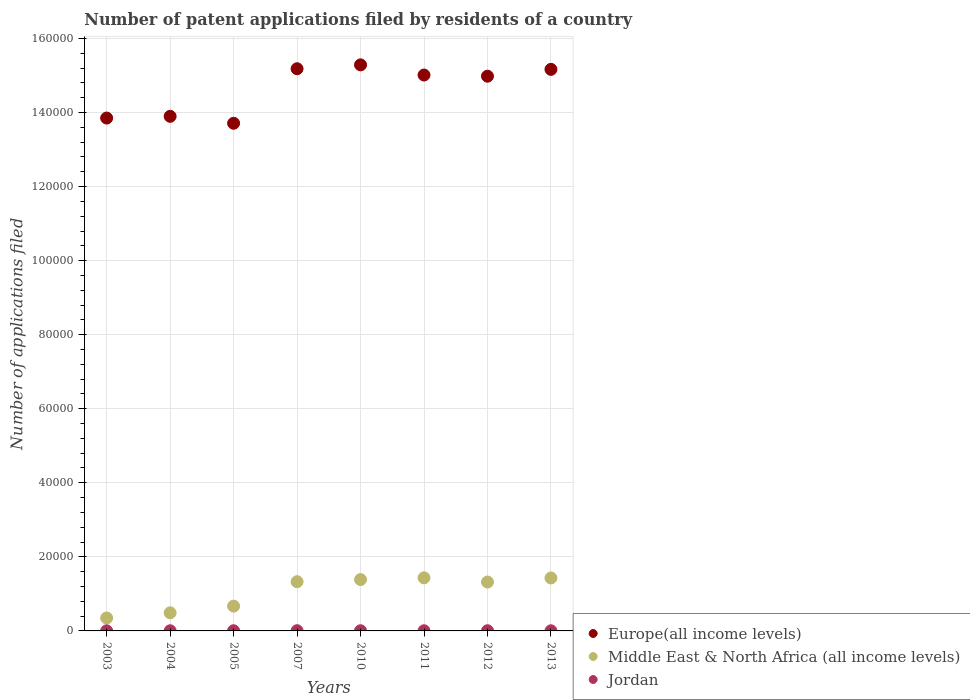Is the number of dotlines equal to the number of legend labels?
Your answer should be very brief. Yes. Across all years, what is the maximum number of applications filed in Middle East & North Africa (all income levels)?
Provide a short and direct response. 1.43e+04. In which year was the number of applications filed in Europe(all income levels) maximum?
Make the answer very short. 2010. In which year was the number of applications filed in Europe(all income levels) minimum?
Offer a very short reply. 2005. What is the total number of applications filed in Middle East & North Africa (all income levels) in the graph?
Your answer should be compact. 8.41e+04. What is the difference between the number of applications filed in Jordan in 2004 and that in 2012?
Keep it short and to the point. -6. What is the difference between the number of applications filed in Jordan in 2004 and the number of applications filed in Europe(all income levels) in 2005?
Your answer should be very brief. -1.37e+05. What is the average number of applications filed in Europe(all income levels) per year?
Provide a succinct answer. 1.46e+05. In the year 2010, what is the difference between the number of applications filed in Europe(all income levels) and number of applications filed in Jordan?
Offer a terse response. 1.53e+05. In how many years, is the number of applications filed in Middle East & North Africa (all income levels) greater than 56000?
Keep it short and to the point. 0. What is the ratio of the number of applications filed in Middle East & North Africa (all income levels) in 2003 to that in 2005?
Make the answer very short. 0.52. Is the difference between the number of applications filed in Europe(all income levels) in 2004 and 2012 greater than the difference between the number of applications filed in Jordan in 2004 and 2012?
Your answer should be very brief. No. What is the difference between the highest and the lowest number of applications filed in Europe(all income levels)?
Ensure brevity in your answer.  1.58e+04. In how many years, is the number of applications filed in Europe(all income levels) greater than the average number of applications filed in Europe(all income levels) taken over all years?
Provide a short and direct response. 5. Is the number of applications filed in Middle East & North Africa (all income levels) strictly less than the number of applications filed in Jordan over the years?
Your response must be concise. No. How many years are there in the graph?
Make the answer very short. 8. What is the difference between two consecutive major ticks on the Y-axis?
Ensure brevity in your answer.  2.00e+04. Are the values on the major ticks of Y-axis written in scientific E-notation?
Provide a short and direct response. No. Does the graph contain any zero values?
Keep it short and to the point. No. Where does the legend appear in the graph?
Provide a succinct answer. Bottom right. How many legend labels are there?
Give a very brief answer. 3. How are the legend labels stacked?
Ensure brevity in your answer.  Vertical. What is the title of the graph?
Your answer should be compact. Number of patent applications filed by residents of a country. Does "Myanmar" appear as one of the legend labels in the graph?
Your response must be concise. No. What is the label or title of the Y-axis?
Offer a terse response. Number of applications filed. What is the Number of applications filed in Europe(all income levels) in 2003?
Offer a terse response. 1.39e+05. What is the Number of applications filed in Middle East & North Africa (all income levels) in 2003?
Offer a terse response. 3484. What is the Number of applications filed in Europe(all income levels) in 2004?
Offer a terse response. 1.39e+05. What is the Number of applications filed in Middle East & North Africa (all income levels) in 2004?
Your response must be concise. 4898. What is the Number of applications filed of Europe(all income levels) in 2005?
Provide a succinct answer. 1.37e+05. What is the Number of applications filed in Middle East & North Africa (all income levels) in 2005?
Keep it short and to the point. 6696. What is the Number of applications filed in Europe(all income levels) in 2007?
Provide a short and direct response. 1.52e+05. What is the Number of applications filed of Middle East & North Africa (all income levels) in 2007?
Offer a terse response. 1.33e+04. What is the Number of applications filed of Europe(all income levels) in 2010?
Your answer should be compact. 1.53e+05. What is the Number of applications filed of Middle East & North Africa (all income levels) in 2010?
Your response must be concise. 1.39e+04. What is the Number of applications filed in Europe(all income levels) in 2011?
Offer a very short reply. 1.50e+05. What is the Number of applications filed in Middle East & North Africa (all income levels) in 2011?
Offer a very short reply. 1.43e+04. What is the Number of applications filed in Europe(all income levels) in 2012?
Ensure brevity in your answer.  1.50e+05. What is the Number of applications filed of Middle East & North Africa (all income levels) in 2012?
Your answer should be compact. 1.32e+04. What is the Number of applications filed of Europe(all income levels) in 2013?
Offer a very short reply. 1.52e+05. What is the Number of applications filed in Middle East & North Africa (all income levels) in 2013?
Provide a succinct answer. 1.43e+04. What is the Number of applications filed in Jordan in 2013?
Your answer should be compact. 35. Across all years, what is the maximum Number of applications filed in Europe(all income levels)?
Your answer should be compact. 1.53e+05. Across all years, what is the maximum Number of applications filed of Middle East & North Africa (all income levels)?
Provide a succinct answer. 1.43e+04. Across all years, what is the maximum Number of applications filed of Jordan?
Offer a very short reply. 59. Across all years, what is the minimum Number of applications filed in Europe(all income levels)?
Give a very brief answer. 1.37e+05. Across all years, what is the minimum Number of applications filed in Middle East & North Africa (all income levels)?
Your response must be concise. 3484. What is the total Number of applications filed in Europe(all income levels) in the graph?
Offer a terse response. 1.17e+06. What is the total Number of applications filed in Middle East & North Africa (all income levels) in the graph?
Give a very brief answer. 8.41e+04. What is the total Number of applications filed in Jordan in the graph?
Keep it short and to the point. 343. What is the difference between the Number of applications filed in Europe(all income levels) in 2003 and that in 2004?
Keep it short and to the point. -467. What is the difference between the Number of applications filed in Middle East & North Africa (all income levels) in 2003 and that in 2004?
Your answer should be compact. -1414. What is the difference between the Number of applications filed in Jordan in 2003 and that in 2004?
Your answer should be compact. -17. What is the difference between the Number of applications filed in Europe(all income levels) in 2003 and that in 2005?
Provide a short and direct response. 1405. What is the difference between the Number of applications filed in Middle East & North Africa (all income levels) in 2003 and that in 2005?
Ensure brevity in your answer.  -3212. What is the difference between the Number of applications filed in Europe(all income levels) in 2003 and that in 2007?
Provide a succinct answer. -1.33e+04. What is the difference between the Number of applications filed in Middle East & North Africa (all income levels) in 2003 and that in 2007?
Your answer should be compact. -9813. What is the difference between the Number of applications filed in Jordan in 2003 and that in 2007?
Make the answer very short. -34. What is the difference between the Number of applications filed in Europe(all income levels) in 2003 and that in 2010?
Ensure brevity in your answer.  -1.44e+04. What is the difference between the Number of applications filed of Middle East & North Africa (all income levels) in 2003 and that in 2010?
Give a very brief answer. -1.04e+04. What is the difference between the Number of applications filed of Jordan in 2003 and that in 2010?
Your response must be concise. -20. What is the difference between the Number of applications filed in Europe(all income levels) in 2003 and that in 2011?
Offer a very short reply. -1.16e+04. What is the difference between the Number of applications filed in Middle East & North Africa (all income levels) in 2003 and that in 2011?
Provide a short and direct response. -1.09e+04. What is the difference between the Number of applications filed in Europe(all income levels) in 2003 and that in 2012?
Make the answer very short. -1.13e+04. What is the difference between the Number of applications filed of Middle East & North Africa (all income levels) in 2003 and that in 2012?
Your response must be concise. -9727. What is the difference between the Number of applications filed of Europe(all income levels) in 2003 and that in 2013?
Provide a succinct answer. -1.32e+04. What is the difference between the Number of applications filed of Middle East & North Africa (all income levels) in 2003 and that in 2013?
Give a very brief answer. -1.08e+04. What is the difference between the Number of applications filed in Europe(all income levels) in 2004 and that in 2005?
Ensure brevity in your answer.  1872. What is the difference between the Number of applications filed in Middle East & North Africa (all income levels) in 2004 and that in 2005?
Your answer should be compact. -1798. What is the difference between the Number of applications filed of Europe(all income levels) in 2004 and that in 2007?
Provide a succinct answer. -1.29e+04. What is the difference between the Number of applications filed of Middle East & North Africa (all income levels) in 2004 and that in 2007?
Keep it short and to the point. -8399. What is the difference between the Number of applications filed of Jordan in 2004 and that in 2007?
Your answer should be compact. -17. What is the difference between the Number of applications filed in Europe(all income levels) in 2004 and that in 2010?
Provide a short and direct response. -1.39e+04. What is the difference between the Number of applications filed of Middle East & North Africa (all income levels) in 2004 and that in 2010?
Make the answer very short. -8971. What is the difference between the Number of applications filed in Jordan in 2004 and that in 2010?
Keep it short and to the point. -3. What is the difference between the Number of applications filed in Europe(all income levels) in 2004 and that in 2011?
Offer a terse response. -1.12e+04. What is the difference between the Number of applications filed of Middle East & North Africa (all income levels) in 2004 and that in 2011?
Your response must be concise. -9439. What is the difference between the Number of applications filed in Jordan in 2004 and that in 2011?
Offer a very short reply. 2. What is the difference between the Number of applications filed in Europe(all income levels) in 2004 and that in 2012?
Offer a very short reply. -1.08e+04. What is the difference between the Number of applications filed of Middle East & North Africa (all income levels) in 2004 and that in 2012?
Ensure brevity in your answer.  -8313. What is the difference between the Number of applications filed of Europe(all income levels) in 2004 and that in 2013?
Your answer should be very brief. -1.27e+04. What is the difference between the Number of applications filed of Middle East & North Africa (all income levels) in 2004 and that in 2013?
Your response must be concise. -9408. What is the difference between the Number of applications filed of Europe(all income levels) in 2005 and that in 2007?
Your answer should be very brief. -1.47e+04. What is the difference between the Number of applications filed of Middle East & North Africa (all income levels) in 2005 and that in 2007?
Make the answer very short. -6601. What is the difference between the Number of applications filed of Europe(all income levels) in 2005 and that in 2010?
Provide a succinct answer. -1.58e+04. What is the difference between the Number of applications filed of Middle East & North Africa (all income levels) in 2005 and that in 2010?
Your answer should be compact. -7173. What is the difference between the Number of applications filed in Europe(all income levels) in 2005 and that in 2011?
Offer a very short reply. -1.30e+04. What is the difference between the Number of applications filed of Middle East & North Africa (all income levels) in 2005 and that in 2011?
Offer a very short reply. -7641. What is the difference between the Number of applications filed in Europe(all income levels) in 2005 and that in 2012?
Your answer should be compact. -1.27e+04. What is the difference between the Number of applications filed of Middle East & North Africa (all income levels) in 2005 and that in 2012?
Provide a succinct answer. -6515. What is the difference between the Number of applications filed in Jordan in 2005 and that in 2012?
Ensure brevity in your answer.  1. What is the difference between the Number of applications filed of Europe(all income levels) in 2005 and that in 2013?
Your answer should be compact. -1.46e+04. What is the difference between the Number of applications filed in Middle East & North Africa (all income levels) in 2005 and that in 2013?
Your answer should be compact. -7610. What is the difference between the Number of applications filed in Jordan in 2005 and that in 2013?
Keep it short and to the point. 14. What is the difference between the Number of applications filed in Europe(all income levels) in 2007 and that in 2010?
Provide a succinct answer. -1043. What is the difference between the Number of applications filed in Middle East & North Africa (all income levels) in 2007 and that in 2010?
Offer a terse response. -572. What is the difference between the Number of applications filed of Europe(all income levels) in 2007 and that in 2011?
Offer a terse response. 1699. What is the difference between the Number of applications filed in Middle East & North Africa (all income levels) in 2007 and that in 2011?
Make the answer very short. -1040. What is the difference between the Number of applications filed in Jordan in 2007 and that in 2011?
Offer a very short reply. 19. What is the difference between the Number of applications filed of Europe(all income levels) in 2007 and that in 2012?
Provide a short and direct response. 2016. What is the difference between the Number of applications filed in Europe(all income levels) in 2007 and that in 2013?
Provide a short and direct response. 171. What is the difference between the Number of applications filed in Middle East & North Africa (all income levels) in 2007 and that in 2013?
Give a very brief answer. -1009. What is the difference between the Number of applications filed in Europe(all income levels) in 2010 and that in 2011?
Make the answer very short. 2742. What is the difference between the Number of applications filed of Middle East & North Africa (all income levels) in 2010 and that in 2011?
Offer a terse response. -468. What is the difference between the Number of applications filed in Jordan in 2010 and that in 2011?
Keep it short and to the point. 5. What is the difference between the Number of applications filed in Europe(all income levels) in 2010 and that in 2012?
Your answer should be very brief. 3059. What is the difference between the Number of applications filed of Middle East & North Africa (all income levels) in 2010 and that in 2012?
Your answer should be very brief. 658. What is the difference between the Number of applications filed in Jordan in 2010 and that in 2012?
Offer a very short reply. -3. What is the difference between the Number of applications filed of Europe(all income levels) in 2010 and that in 2013?
Provide a short and direct response. 1214. What is the difference between the Number of applications filed in Middle East & North Africa (all income levels) in 2010 and that in 2013?
Provide a short and direct response. -437. What is the difference between the Number of applications filed in Jordan in 2010 and that in 2013?
Make the answer very short. 10. What is the difference between the Number of applications filed of Europe(all income levels) in 2011 and that in 2012?
Give a very brief answer. 317. What is the difference between the Number of applications filed in Middle East & North Africa (all income levels) in 2011 and that in 2012?
Your answer should be compact. 1126. What is the difference between the Number of applications filed in Europe(all income levels) in 2011 and that in 2013?
Your response must be concise. -1528. What is the difference between the Number of applications filed of Middle East & North Africa (all income levels) in 2011 and that in 2013?
Your answer should be compact. 31. What is the difference between the Number of applications filed of Jordan in 2011 and that in 2013?
Your answer should be compact. 5. What is the difference between the Number of applications filed in Europe(all income levels) in 2012 and that in 2013?
Offer a very short reply. -1845. What is the difference between the Number of applications filed in Middle East & North Africa (all income levels) in 2012 and that in 2013?
Make the answer very short. -1095. What is the difference between the Number of applications filed in Jordan in 2012 and that in 2013?
Make the answer very short. 13. What is the difference between the Number of applications filed in Europe(all income levels) in 2003 and the Number of applications filed in Middle East & North Africa (all income levels) in 2004?
Provide a short and direct response. 1.34e+05. What is the difference between the Number of applications filed of Europe(all income levels) in 2003 and the Number of applications filed of Jordan in 2004?
Your answer should be very brief. 1.38e+05. What is the difference between the Number of applications filed of Middle East & North Africa (all income levels) in 2003 and the Number of applications filed of Jordan in 2004?
Your answer should be compact. 3442. What is the difference between the Number of applications filed of Europe(all income levels) in 2003 and the Number of applications filed of Middle East & North Africa (all income levels) in 2005?
Provide a succinct answer. 1.32e+05. What is the difference between the Number of applications filed in Europe(all income levels) in 2003 and the Number of applications filed in Jordan in 2005?
Offer a very short reply. 1.38e+05. What is the difference between the Number of applications filed of Middle East & North Africa (all income levels) in 2003 and the Number of applications filed of Jordan in 2005?
Your answer should be very brief. 3435. What is the difference between the Number of applications filed in Europe(all income levels) in 2003 and the Number of applications filed in Middle East & North Africa (all income levels) in 2007?
Offer a very short reply. 1.25e+05. What is the difference between the Number of applications filed of Europe(all income levels) in 2003 and the Number of applications filed of Jordan in 2007?
Provide a succinct answer. 1.38e+05. What is the difference between the Number of applications filed in Middle East & North Africa (all income levels) in 2003 and the Number of applications filed in Jordan in 2007?
Ensure brevity in your answer.  3425. What is the difference between the Number of applications filed in Europe(all income levels) in 2003 and the Number of applications filed in Middle East & North Africa (all income levels) in 2010?
Offer a very short reply. 1.25e+05. What is the difference between the Number of applications filed of Europe(all income levels) in 2003 and the Number of applications filed of Jordan in 2010?
Ensure brevity in your answer.  1.38e+05. What is the difference between the Number of applications filed in Middle East & North Africa (all income levels) in 2003 and the Number of applications filed in Jordan in 2010?
Keep it short and to the point. 3439. What is the difference between the Number of applications filed in Europe(all income levels) in 2003 and the Number of applications filed in Middle East & North Africa (all income levels) in 2011?
Keep it short and to the point. 1.24e+05. What is the difference between the Number of applications filed in Europe(all income levels) in 2003 and the Number of applications filed in Jordan in 2011?
Ensure brevity in your answer.  1.38e+05. What is the difference between the Number of applications filed in Middle East & North Africa (all income levels) in 2003 and the Number of applications filed in Jordan in 2011?
Ensure brevity in your answer.  3444. What is the difference between the Number of applications filed of Europe(all income levels) in 2003 and the Number of applications filed of Middle East & North Africa (all income levels) in 2012?
Keep it short and to the point. 1.25e+05. What is the difference between the Number of applications filed in Europe(all income levels) in 2003 and the Number of applications filed in Jordan in 2012?
Give a very brief answer. 1.38e+05. What is the difference between the Number of applications filed in Middle East & North Africa (all income levels) in 2003 and the Number of applications filed in Jordan in 2012?
Your answer should be compact. 3436. What is the difference between the Number of applications filed of Europe(all income levels) in 2003 and the Number of applications filed of Middle East & North Africa (all income levels) in 2013?
Keep it short and to the point. 1.24e+05. What is the difference between the Number of applications filed in Europe(all income levels) in 2003 and the Number of applications filed in Jordan in 2013?
Ensure brevity in your answer.  1.38e+05. What is the difference between the Number of applications filed in Middle East & North Africa (all income levels) in 2003 and the Number of applications filed in Jordan in 2013?
Your answer should be compact. 3449. What is the difference between the Number of applications filed in Europe(all income levels) in 2004 and the Number of applications filed in Middle East & North Africa (all income levels) in 2005?
Your response must be concise. 1.32e+05. What is the difference between the Number of applications filed in Europe(all income levels) in 2004 and the Number of applications filed in Jordan in 2005?
Your answer should be compact. 1.39e+05. What is the difference between the Number of applications filed of Middle East & North Africa (all income levels) in 2004 and the Number of applications filed of Jordan in 2005?
Provide a short and direct response. 4849. What is the difference between the Number of applications filed of Europe(all income levels) in 2004 and the Number of applications filed of Middle East & North Africa (all income levels) in 2007?
Your response must be concise. 1.26e+05. What is the difference between the Number of applications filed in Europe(all income levels) in 2004 and the Number of applications filed in Jordan in 2007?
Your response must be concise. 1.39e+05. What is the difference between the Number of applications filed of Middle East & North Africa (all income levels) in 2004 and the Number of applications filed of Jordan in 2007?
Offer a terse response. 4839. What is the difference between the Number of applications filed in Europe(all income levels) in 2004 and the Number of applications filed in Middle East & North Africa (all income levels) in 2010?
Provide a short and direct response. 1.25e+05. What is the difference between the Number of applications filed of Europe(all income levels) in 2004 and the Number of applications filed of Jordan in 2010?
Give a very brief answer. 1.39e+05. What is the difference between the Number of applications filed of Middle East & North Africa (all income levels) in 2004 and the Number of applications filed of Jordan in 2010?
Make the answer very short. 4853. What is the difference between the Number of applications filed of Europe(all income levels) in 2004 and the Number of applications filed of Middle East & North Africa (all income levels) in 2011?
Keep it short and to the point. 1.25e+05. What is the difference between the Number of applications filed of Europe(all income levels) in 2004 and the Number of applications filed of Jordan in 2011?
Offer a terse response. 1.39e+05. What is the difference between the Number of applications filed in Middle East & North Africa (all income levels) in 2004 and the Number of applications filed in Jordan in 2011?
Your response must be concise. 4858. What is the difference between the Number of applications filed in Europe(all income levels) in 2004 and the Number of applications filed in Middle East & North Africa (all income levels) in 2012?
Ensure brevity in your answer.  1.26e+05. What is the difference between the Number of applications filed of Europe(all income levels) in 2004 and the Number of applications filed of Jordan in 2012?
Your response must be concise. 1.39e+05. What is the difference between the Number of applications filed of Middle East & North Africa (all income levels) in 2004 and the Number of applications filed of Jordan in 2012?
Ensure brevity in your answer.  4850. What is the difference between the Number of applications filed in Europe(all income levels) in 2004 and the Number of applications filed in Middle East & North Africa (all income levels) in 2013?
Your answer should be compact. 1.25e+05. What is the difference between the Number of applications filed in Europe(all income levels) in 2004 and the Number of applications filed in Jordan in 2013?
Make the answer very short. 1.39e+05. What is the difference between the Number of applications filed of Middle East & North Africa (all income levels) in 2004 and the Number of applications filed of Jordan in 2013?
Make the answer very short. 4863. What is the difference between the Number of applications filed of Europe(all income levels) in 2005 and the Number of applications filed of Middle East & North Africa (all income levels) in 2007?
Provide a short and direct response. 1.24e+05. What is the difference between the Number of applications filed of Europe(all income levels) in 2005 and the Number of applications filed of Jordan in 2007?
Your response must be concise. 1.37e+05. What is the difference between the Number of applications filed of Middle East & North Africa (all income levels) in 2005 and the Number of applications filed of Jordan in 2007?
Offer a very short reply. 6637. What is the difference between the Number of applications filed of Europe(all income levels) in 2005 and the Number of applications filed of Middle East & North Africa (all income levels) in 2010?
Provide a succinct answer. 1.23e+05. What is the difference between the Number of applications filed of Europe(all income levels) in 2005 and the Number of applications filed of Jordan in 2010?
Your answer should be very brief. 1.37e+05. What is the difference between the Number of applications filed of Middle East & North Africa (all income levels) in 2005 and the Number of applications filed of Jordan in 2010?
Provide a succinct answer. 6651. What is the difference between the Number of applications filed of Europe(all income levels) in 2005 and the Number of applications filed of Middle East & North Africa (all income levels) in 2011?
Make the answer very short. 1.23e+05. What is the difference between the Number of applications filed of Europe(all income levels) in 2005 and the Number of applications filed of Jordan in 2011?
Your answer should be very brief. 1.37e+05. What is the difference between the Number of applications filed of Middle East & North Africa (all income levels) in 2005 and the Number of applications filed of Jordan in 2011?
Make the answer very short. 6656. What is the difference between the Number of applications filed in Europe(all income levels) in 2005 and the Number of applications filed in Middle East & North Africa (all income levels) in 2012?
Offer a terse response. 1.24e+05. What is the difference between the Number of applications filed of Europe(all income levels) in 2005 and the Number of applications filed of Jordan in 2012?
Your answer should be compact. 1.37e+05. What is the difference between the Number of applications filed of Middle East & North Africa (all income levels) in 2005 and the Number of applications filed of Jordan in 2012?
Your response must be concise. 6648. What is the difference between the Number of applications filed in Europe(all income levels) in 2005 and the Number of applications filed in Middle East & North Africa (all income levels) in 2013?
Ensure brevity in your answer.  1.23e+05. What is the difference between the Number of applications filed of Europe(all income levels) in 2005 and the Number of applications filed of Jordan in 2013?
Your answer should be compact. 1.37e+05. What is the difference between the Number of applications filed in Middle East & North Africa (all income levels) in 2005 and the Number of applications filed in Jordan in 2013?
Make the answer very short. 6661. What is the difference between the Number of applications filed in Europe(all income levels) in 2007 and the Number of applications filed in Middle East & North Africa (all income levels) in 2010?
Offer a very short reply. 1.38e+05. What is the difference between the Number of applications filed in Europe(all income levels) in 2007 and the Number of applications filed in Jordan in 2010?
Your answer should be compact. 1.52e+05. What is the difference between the Number of applications filed in Middle East & North Africa (all income levels) in 2007 and the Number of applications filed in Jordan in 2010?
Offer a very short reply. 1.33e+04. What is the difference between the Number of applications filed in Europe(all income levels) in 2007 and the Number of applications filed in Middle East & North Africa (all income levels) in 2011?
Offer a very short reply. 1.37e+05. What is the difference between the Number of applications filed in Europe(all income levels) in 2007 and the Number of applications filed in Jordan in 2011?
Keep it short and to the point. 1.52e+05. What is the difference between the Number of applications filed of Middle East & North Africa (all income levels) in 2007 and the Number of applications filed of Jordan in 2011?
Make the answer very short. 1.33e+04. What is the difference between the Number of applications filed in Europe(all income levels) in 2007 and the Number of applications filed in Middle East & North Africa (all income levels) in 2012?
Your answer should be compact. 1.39e+05. What is the difference between the Number of applications filed in Europe(all income levels) in 2007 and the Number of applications filed in Jordan in 2012?
Provide a short and direct response. 1.52e+05. What is the difference between the Number of applications filed in Middle East & North Africa (all income levels) in 2007 and the Number of applications filed in Jordan in 2012?
Make the answer very short. 1.32e+04. What is the difference between the Number of applications filed of Europe(all income levels) in 2007 and the Number of applications filed of Middle East & North Africa (all income levels) in 2013?
Make the answer very short. 1.38e+05. What is the difference between the Number of applications filed of Europe(all income levels) in 2007 and the Number of applications filed of Jordan in 2013?
Ensure brevity in your answer.  1.52e+05. What is the difference between the Number of applications filed of Middle East & North Africa (all income levels) in 2007 and the Number of applications filed of Jordan in 2013?
Make the answer very short. 1.33e+04. What is the difference between the Number of applications filed of Europe(all income levels) in 2010 and the Number of applications filed of Middle East & North Africa (all income levels) in 2011?
Your answer should be compact. 1.39e+05. What is the difference between the Number of applications filed of Europe(all income levels) in 2010 and the Number of applications filed of Jordan in 2011?
Offer a terse response. 1.53e+05. What is the difference between the Number of applications filed in Middle East & North Africa (all income levels) in 2010 and the Number of applications filed in Jordan in 2011?
Provide a succinct answer. 1.38e+04. What is the difference between the Number of applications filed in Europe(all income levels) in 2010 and the Number of applications filed in Middle East & North Africa (all income levels) in 2012?
Your answer should be very brief. 1.40e+05. What is the difference between the Number of applications filed of Europe(all income levels) in 2010 and the Number of applications filed of Jordan in 2012?
Ensure brevity in your answer.  1.53e+05. What is the difference between the Number of applications filed of Middle East & North Africa (all income levels) in 2010 and the Number of applications filed of Jordan in 2012?
Your answer should be very brief. 1.38e+04. What is the difference between the Number of applications filed in Europe(all income levels) in 2010 and the Number of applications filed in Middle East & North Africa (all income levels) in 2013?
Your answer should be compact. 1.39e+05. What is the difference between the Number of applications filed in Europe(all income levels) in 2010 and the Number of applications filed in Jordan in 2013?
Offer a terse response. 1.53e+05. What is the difference between the Number of applications filed in Middle East & North Africa (all income levels) in 2010 and the Number of applications filed in Jordan in 2013?
Provide a succinct answer. 1.38e+04. What is the difference between the Number of applications filed of Europe(all income levels) in 2011 and the Number of applications filed of Middle East & North Africa (all income levels) in 2012?
Provide a succinct answer. 1.37e+05. What is the difference between the Number of applications filed in Europe(all income levels) in 2011 and the Number of applications filed in Jordan in 2012?
Your response must be concise. 1.50e+05. What is the difference between the Number of applications filed of Middle East & North Africa (all income levels) in 2011 and the Number of applications filed of Jordan in 2012?
Keep it short and to the point. 1.43e+04. What is the difference between the Number of applications filed in Europe(all income levels) in 2011 and the Number of applications filed in Middle East & North Africa (all income levels) in 2013?
Your answer should be very brief. 1.36e+05. What is the difference between the Number of applications filed of Europe(all income levels) in 2011 and the Number of applications filed of Jordan in 2013?
Give a very brief answer. 1.50e+05. What is the difference between the Number of applications filed of Middle East & North Africa (all income levels) in 2011 and the Number of applications filed of Jordan in 2013?
Give a very brief answer. 1.43e+04. What is the difference between the Number of applications filed of Europe(all income levels) in 2012 and the Number of applications filed of Middle East & North Africa (all income levels) in 2013?
Provide a succinct answer. 1.36e+05. What is the difference between the Number of applications filed of Europe(all income levels) in 2012 and the Number of applications filed of Jordan in 2013?
Make the answer very short. 1.50e+05. What is the difference between the Number of applications filed in Middle East & North Africa (all income levels) in 2012 and the Number of applications filed in Jordan in 2013?
Provide a short and direct response. 1.32e+04. What is the average Number of applications filed in Europe(all income levels) per year?
Keep it short and to the point. 1.46e+05. What is the average Number of applications filed in Middle East & North Africa (all income levels) per year?
Give a very brief answer. 1.05e+04. What is the average Number of applications filed of Jordan per year?
Make the answer very short. 42.88. In the year 2003, what is the difference between the Number of applications filed of Europe(all income levels) and Number of applications filed of Middle East & North Africa (all income levels)?
Your response must be concise. 1.35e+05. In the year 2003, what is the difference between the Number of applications filed in Europe(all income levels) and Number of applications filed in Jordan?
Offer a terse response. 1.38e+05. In the year 2003, what is the difference between the Number of applications filed of Middle East & North Africa (all income levels) and Number of applications filed of Jordan?
Offer a very short reply. 3459. In the year 2004, what is the difference between the Number of applications filed in Europe(all income levels) and Number of applications filed in Middle East & North Africa (all income levels)?
Provide a short and direct response. 1.34e+05. In the year 2004, what is the difference between the Number of applications filed in Europe(all income levels) and Number of applications filed in Jordan?
Ensure brevity in your answer.  1.39e+05. In the year 2004, what is the difference between the Number of applications filed of Middle East & North Africa (all income levels) and Number of applications filed of Jordan?
Ensure brevity in your answer.  4856. In the year 2005, what is the difference between the Number of applications filed in Europe(all income levels) and Number of applications filed in Middle East & North Africa (all income levels)?
Offer a terse response. 1.30e+05. In the year 2005, what is the difference between the Number of applications filed of Europe(all income levels) and Number of applications filed of Jordan?
Your answer should be compact. 1.37e+05. In the year 2005, what is the difference between the Number of applications filed of Middle East & North Africa (all income levels) and Number of applications filed of Jordan?
Offer a very short reply. 6647. In the year 2007, what is the difference between the Number of applications filed in Europe(all income levels) and Number of applications filed in Middle East & North Africa (all income levels)?
Your answer should be compact. 1.39e+05. In the year 2007, what is the difference between the Number of applications filed in Europe(all income levels) and Number of applications filed in Jordan?
Offer a very short reply. 1.52e+05. In the year 2007, what is the difference between the Number of applications filed of Middle East & North Africa (all income levels) and Number of applications filed of Jordan?
Ensure brevity in your answer.  1.32e+04. In the year 2010, what is the difference between the Number of applications filed of Europe(all income levels) and Number of applications filed of Middle East & North Africa (all income levels)?
Offer a terse response. 1.39e+05. In the year 2010, what is the difference between the Number of applications filed of Europe(all income levels) and Number of applications filed of Jordan?
Provide a short and direct response. 1.53e+05. In the year 2010, what is the difference between the Number of applications filed in Middle East & North Africa (all income levels) and Number of applications filed in Jordan?
Provide a succinct answer. 1.38e+04. In the year 2011, what is the difference between the Number of applications filed of Europe(all income levels) and Number of applications filed of Middle East & North Africa (all income levels)?
Provide a succinct answer. 1.36e+05. In the year 2011, what is the difference between the Number of applications filed in Europe(all income levels) and Number of applications filed in Jordan?
Make the answer very short. 1.50e+05. In the year 2011, what is the difference between the Number of applications filed of Middle East & North Africa (all income levels) and Number of applications filed of Jordan?
Your answer should be compact. 1.43e+04. In the year 2012, what is the difference between the Number of applications filed in Europe(all income levels) and Number of applications filed in Middle East & North Africa (all income levels)?
Ensure brevity in your answer.  1.37e+05. In the year 2012, what is the difference between the Number of applications filed of Europe(all income levels) and Number of applications filed of Jordan?
Keep it short and to the point. 1.50e+05. In the year 2012, what is the difference between the Number of applications filed in Middle East & North Africa (all income levels) and Number of applications filed in Jordan?
Your answer should be compact. 1.32e+04. In the year 2013, what is the difference between the Number of applications filed in Europe(all income levels) and Number of applications filed in Middle East & North Africa (all income levels)?
Make the answer very short. 1.37e+05. In the year 2013, what is the difference between the Number of applications filed in Europe(all income levels) and Number of applications filed in Jordan?
Offer a very short reply. 1.52e+05. In the year 2013, what is the difference between the Number of applications filed of Middle East & North Africa (all income levels) and Number of applications filed of Jordan?
Provide a short and direct response. 1.43e+04. What is the ratio of the Number of applications filed in Europe(all income levels) in 2003 to that in 2004?
Your answer should be compact. 1. What is the ratio of the Number of applications filed of Middle East & North Africa (all income levels) in 2003 to that in 2004?
Keep it short and to the point. 0.71. What is the ratio of the Number of applications filed in Jordan in 2003 to that in 2004?
Offer a terse response. 0.6. What is the ratio of the Number of applications filed of Europe(all income levels) in 2003 to that in 2005?
Your answer should be very brief. 1.01. What is the ratio of the Number of applications filed in Middle East & North Africa (all income levels) in 2003 to that in 2005?
Your response must be concise. 0.52. What is the ratio of the Number of applications filed in Jordan in 2003 to that in 2005?
Ensure brevity in your answer.  0.51. What is the ratio of the Number of applications filed of Europe(all income levels) in 2003 to that in 2007?
Make the answer very short. 0.91. What is the ratio of the Number of applications filed of Middle East & North Africa (all income levels) in 2003 to that in 2007?
Make the answer very short. 0.26. What is the ratio of the Number of applications filed in Jordan in 2003 to that in 2007?
Offer a terse response. 0.42. What is the ratio of the Number of applications filed of Europe(all income levels) in 2003 to that in 2010?
Offer a very short reply. 0.91. What is the ratio of the Number of applications filed of Middle East & North Africa (all income levels) in 2003 to that in 2010?
Provide a succinct answer. 0.25. What is the ratio of the Number of applications filed in Jordan in 2003 to that in 2010?
Ensure brevity in your answer.  0.56. What is the ratio of the Number of applications filed of Europe(all income levels) in 2003 to that in 2011?
Make the answer very short. 0.92. What is the ratio of the Number of applications filed of Middle East & North Africa (all income levels) in 2003 to that in 2011?
Make the answer very short. 0.24. What is the ratio of the Number of applications filed of Jordan in 2003 to that in 2011?
Provide a succinct answer. 0.62. What is the ratio of the Number of applications filed in Europe(all income levels) in 2003 to that in 2012?
Your answer should be compact. 0.92. What is the ratio of the Number of applications filed in Middle East & North Africa (all income levels) in 2003 to that in 2012?
Your answer should be very brief. 0.26. What is the ratio of the Number of applications filed of Jordan in 2003 to that in 2012?
Your answer should be very brief. 0.52. What is the ratio of the Number of applications filed in Europe(all income levels) in 2003 to that in 2013?
Offer a terse response. 0.91. What is the ratio of the Number of applications filed of Middle East & North Africa (all income levels) in 2003 to that in 2013?
Your answer should be compact. 0.24. What is the ratio of the Number of applications filed in Europe(all income levels) in 2004 to that in 2005?
Make the answer very short. 1.01. What is the ratio of the Number of applications filed in Middle East & North Africa (all income levels) in 2004 to that in 2005?
Your response must be concise. 0.73. What is the ratio of the Number of applications filed in Europe(all income levels) in 2004 to that in 2007?
Give a very brief answer. 0.92. What is the ratio of the Number of applications filed of Middle East & North Africa (all income levels) in 2004 to that in 2007?
Offer a very short reply. 0.37. What is the ratio of the Number of applications filed in Jordan in 2004 to that in 2007?
Make the answer very short. 0.71. What is the ratio of the Number of applications filed in Middle East & North Africa (all income levels) in 2004 to that in 2010?
Your answer should be compact. 0.35. What is the ratio of the Number of applications filed of Jordan in 2004 to that in 2010?
Keep it short and to the point. 0.93. What is the ratio of the Number of applications filed of Europe(all income levels) in 2004 to that in 2011?
Your response must be concise. 0.93. What is the ratio of the Number of applications filed of Middle East & North Africa (all income levels) in 2004 to that in 2011?
Offer a terse response. 0.34. What is the ratio of the Number of applications filed in Europe(all income levels) in 2004 to that in 2012?
Provide a short and direct response. 0.93. What is the ratio of the Number of applications filed of Middle East & North Africa (all income levels) in 2004 to that in 2012?
Make the answer very short. 0.37. What is the ratio of the Number of applications filed of Europe(all income levels) in 2004 to that in 2013?
Make the answer very short. 0.92. What is the ratio of the Number of applications filed in Middle East & North Africa (all income levels) in 2004 to that in 2013?
Your answer should be very brief. 0.34. What is the ratio of the Number of applications filed of Europe(all income levels) in 2005 to that in 2007?
Keep it short and to the point. 0.9. What is the ratio of the Number of applications filed of Middle East & North Africa (all income levels) in 2005 to that in 2007?
Provide a short and direct response. 0.5. What is the ratio of the Number of applications filed of Jordan in 2005 to that in 2007?
Keep it short and to the point. 0.83. What is the ratio of the Number of applications filed of Europe(all income levels) in 2005 to that in 2010?
Provide a short and direct response. 0.9. What is the ratio of the Number of applications filed of Middle East & North Africa (all income levels) in 2005 to that in 2010?
Give a very brief answer. 0.48. What is the ratio of the Number of applications filed in Jordan in 2005 to that in 2010?
Provide a short and direct response. 1.09. What is the ratio of the Number of applications filed in Europe(all income levels) in 2005 to that in 2011?
Offer a very short reply. 0.91. What is the ratio of the Number of applications filed in Middle East & North Africa (all income levels) in 2005 to that in 2011?
Make the answer very short. 0.47. What is the ratio of the Number of applications filed of Jordan in 2005 to that in 2011?
Your answer should be compact. 1.23. What is the ratio of the Number of applications filed of Europe(all income levels) in 2005 to that in 2012?
Your answer should be very brief. 0.92. What is the ratio of the Number of applications filed in Middle East & North Africa (all income levels) in 2005 to that in 2012?
Your answer should be compact. 0.51. What is the ratio of the Number of applications filed of Jordan in 2005 to that in 2012?
Your answer should be very brief. 1.02. What is the ratio of the Number of applications filed in Europe(all income levels) in 2005 to that in 2013?
Offer a very short reply. 0.9. What is the ratio of the Number of applications filed in Middle East & North Africa (all income levels) in 2005 to that in 2013?
Provide a short and direct response. 0.47. What is the ratio of the Number of applications filed in Europe(all income levels) in 2007 to that in 2010?
Make the answer very short. 0.99. What is the ratio of the Number of applications filed of Middle East & North Africa (all income levels) in 2007 to that in 2010?
Give a very brief answer. 0.96. What is the ratio of the Number of applications filed of Jordan in 2007 to that in 2010?
Offer a very short reply. 1.31. What is the ratio of the Number of applications filed in Europe(all income levels) in 2007 to that in 2011?
Provide a succinct answer. 1.01. What is the ratio of the Number of applications filed of Middle East & North Africa (all income levels) in 2007 to that in 2011?
Keep it short and to the point. 0.93. What is the ratio of the Number of applications filed in Jordan in 2007 to that in 2011?
Your answer should be compact. 1.48. What is the ratio of the Number of applications filed of Europe(all income levels) in 2007 to that in 2012?
Your response must be concise. 1.01. What is the ratio of the Number of applications filed of Middle East & North Africa (all income levels) in 2007 to that in 2012?
Provide a succinct answer. 1.01. What is the ratio of the Number of applications filed in Jordan in 2007 to that in 2012?
Your answer should be very brief. 1.23. What is the ratio of the Number of applications filed of Europe(all income levels) in 2007 to that in 2013?
Offer a very short reply. 1. What is the ratio of the Number of applications filed in Middle East & North Africa (all income levels) in 2007 to that in 2013?
Your answer should be compact. 0.93. What is the ratio of the Number of applications filed in Jordan in 2007 to that in 2013?
Provide a succinct answer. 1.69. What is the ratio of the Number of applications filed in Europe(all income levels) in 2010 to that in 2011?
Offer a very short reply. 1.02. What is the ratio of the Number of applications filed of Middle East & North Africa (all income levels) in 2010 to that in 2011?
Offer a terse response. 0.97. What is the ratio of the Number of applications filed in Europe(all income levels) in 2010 to that in 2012?
Make the answer very short. 1.02. What is the ratio of the Number of applications filed in Middle East & North Africa (all income levels) in 2010 to that in 2012?
Make the answer very short. 1.05. What is the ratio of the Number of applications filed of Jordan in 2010 to that in 2012?
Your response must be concise. 0.94. What is the ratio of the Number of applications filed of Middle East & North Africa (all income levels) in 2010 to that in 2013?
Your answer should be very brief. 0.97. What is the ratio of the Number of applications filed of Jordan in 2010 to that in 2013?
Make the answer very short. 1.29. What is the ratio of the Number of applications filed of Europe(all income levels) in 2011 to that in 2012?
Provide a succinct answer. 1. What is the ratio of the Number of applications filed of Middle East & North Africa (all income levels) in 2011 to that in 2012?
Provide a short and direct response. 1.09. What is the ratio of the Number of applications filed of Jordan in 2011 to that in 2012?
Make the answer very short. 0.83. What is the ratio of the Number of applications filed in Europe(all income levels) in 2011 to that in 2013?
Offer a terse response. 0.99. What is the ratio of the Number of applications filed in Europe(all income levels) in 2012 to that in 2013?
Make the answer very short. 0.99. What is the ratio of the Number of applications filed of Middle East & North Africa (all income levels) in 2012 to that in 2013?
Provide a short and direct response. 0.92. What is the ratio of the Number of applications filed of Jordan in 2012 to that in 2013?
Provide a succinct answer. 1.37. What is the difference between the highest and the second highest Number of applications filed of Europe(all income levels)?
Keep it short and to the point. 1043. What is the difference between the highest and the second highest Number of applications filed of Middle East & North Africa (all income levels)?
Offer a terse response. 31. What is the difference between the highest and the lowest Number of applications filed in Europe(all income levels)?
Make the answer very short. 1.58e+04. What is the difference between the highest and the lowest Number of applications filed of Middle East & North Africa (all income levels)?
Give a very brief answer. 1.09e+04. 